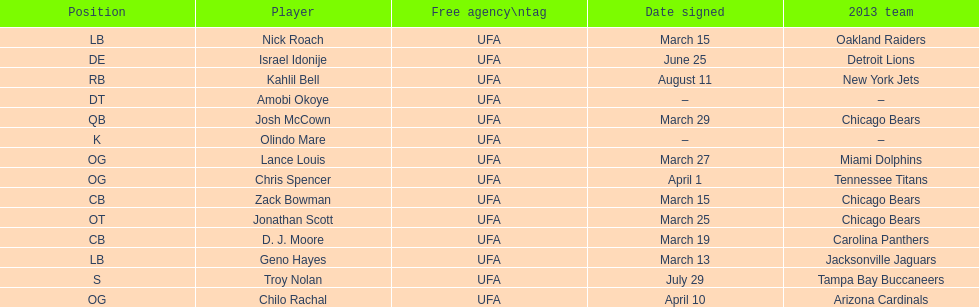The only player to sign in july? Troy Nolan. 